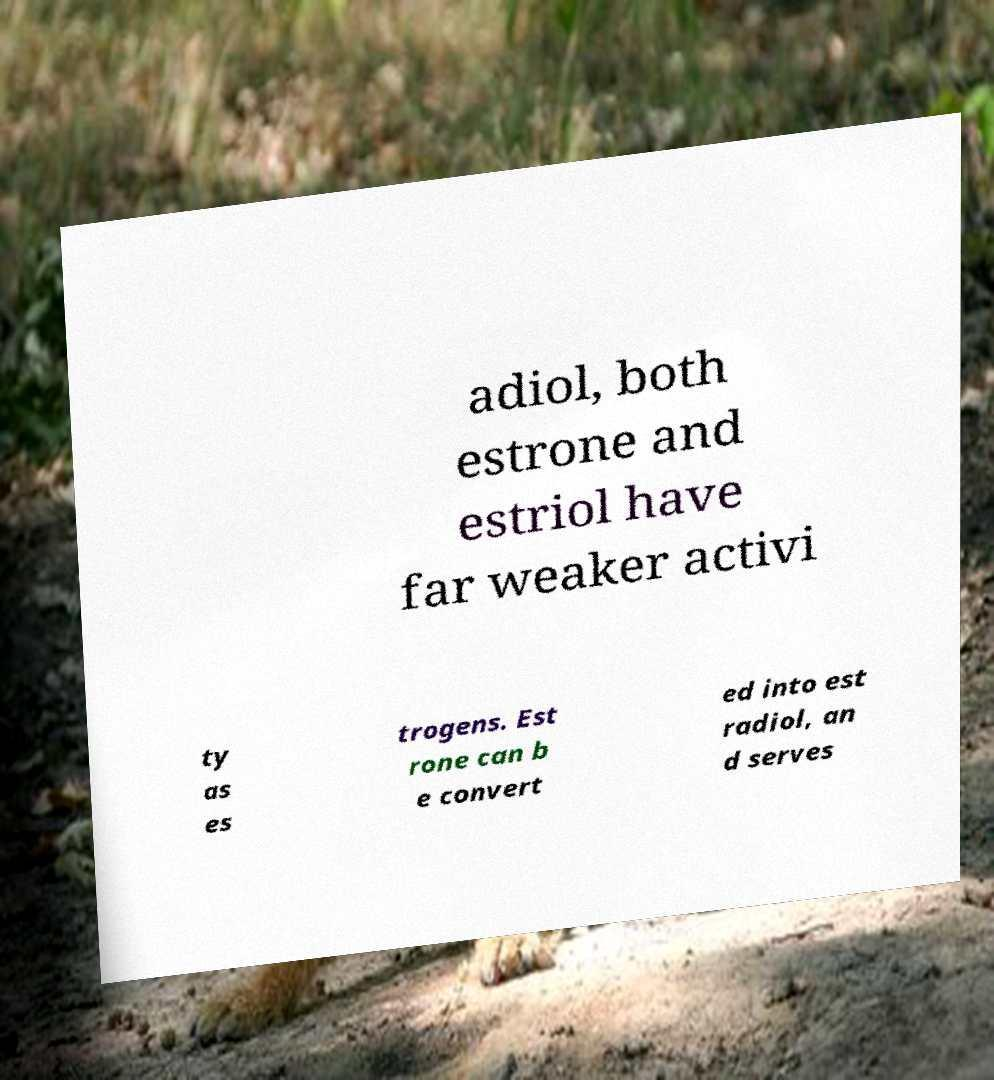Could you extract and type out the text from this image? adiol, both estrone and estriol have far weaker activi ty as es trogens. Est rone can b e convert ed into est radiol, an d serves 